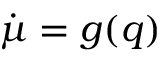<formula> <loc_0><loc_0><loc_500><loc_500>\dot { \mu } = g ( q )</formula> 